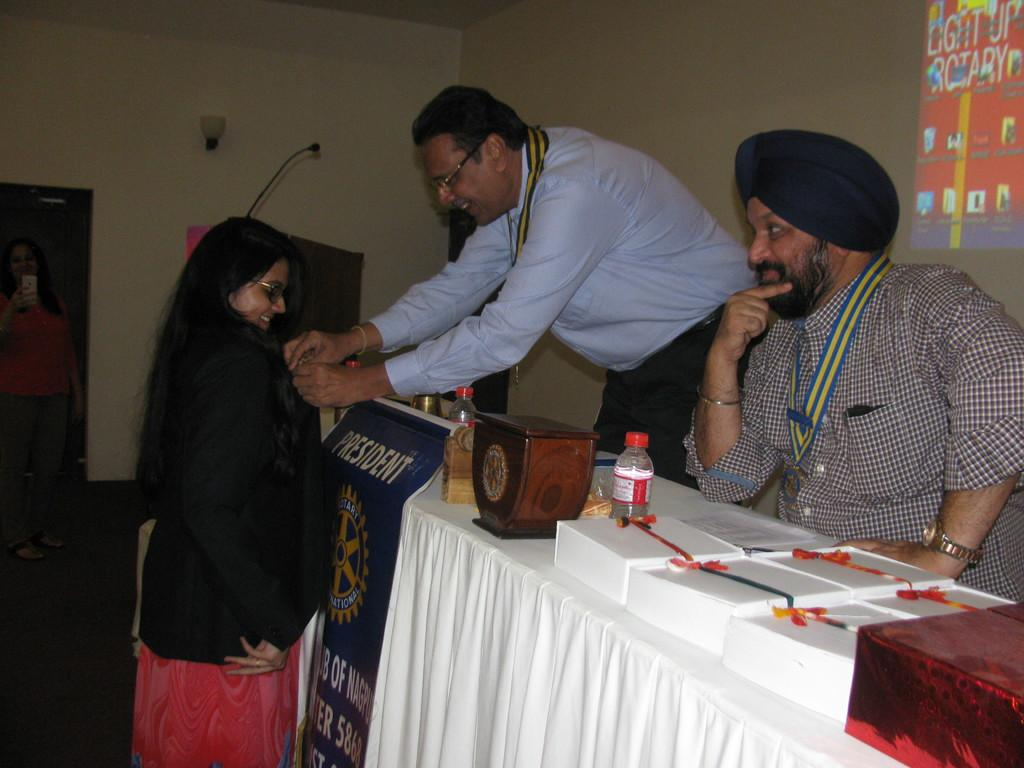Provide a one-sentence caption for the provided image. A man behind a President flag leans over to interact with a young woman. 